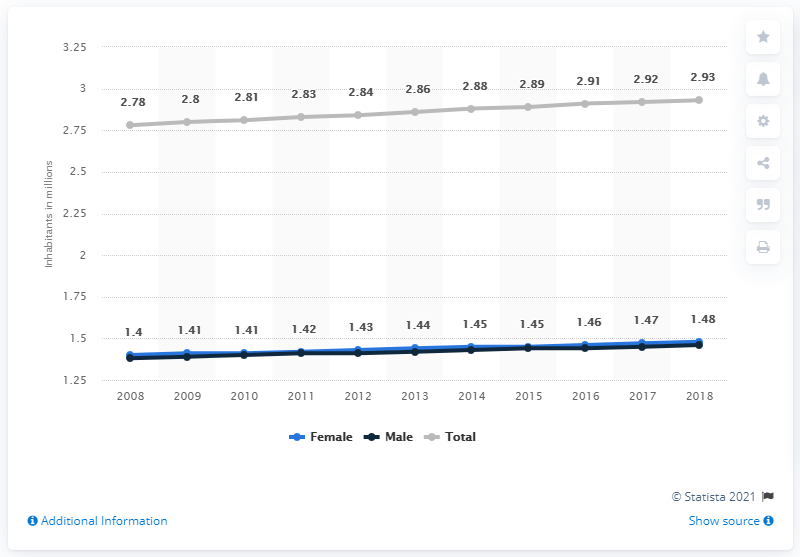Draw attention to some important aspects in this diagram. In 2018, there were approximately 1.46 million men living in Jamaica. The total minimum population is 2.78. The total maximum population is 2.93 billion. In 2018, it is estimated that approximately 1.48 million women lived in Jamaica. In 2008, Jamaica's population began to show an upward trend. 